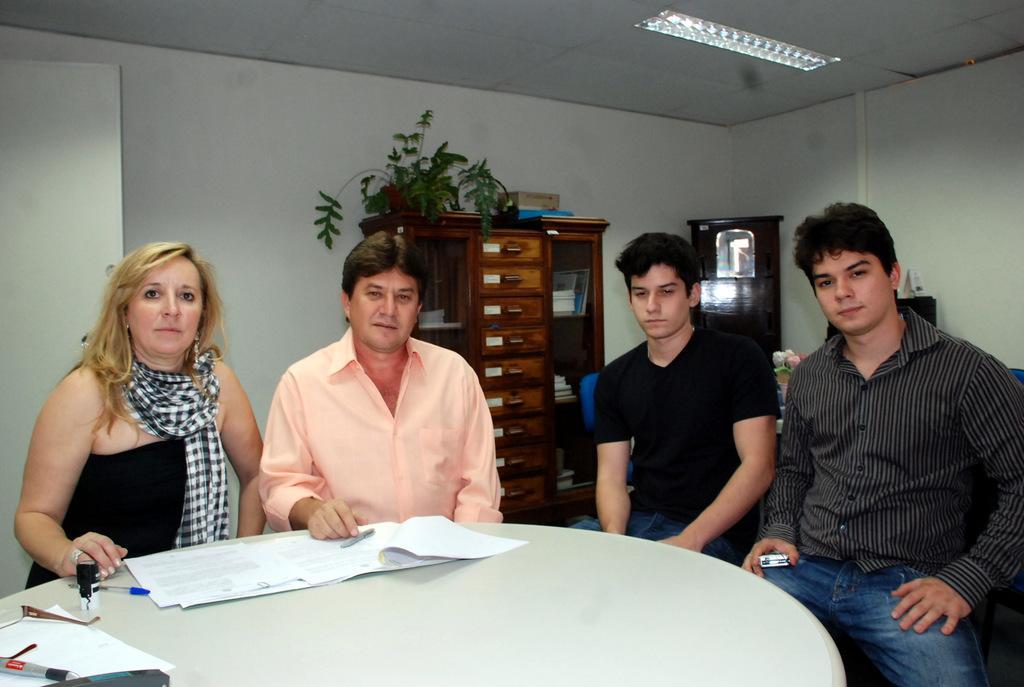Could you give a brief overview of what you see in this image? This picture shows a group of people seated on the chairs and we see some papers,pens on the table and we see a rack and a plant on it 